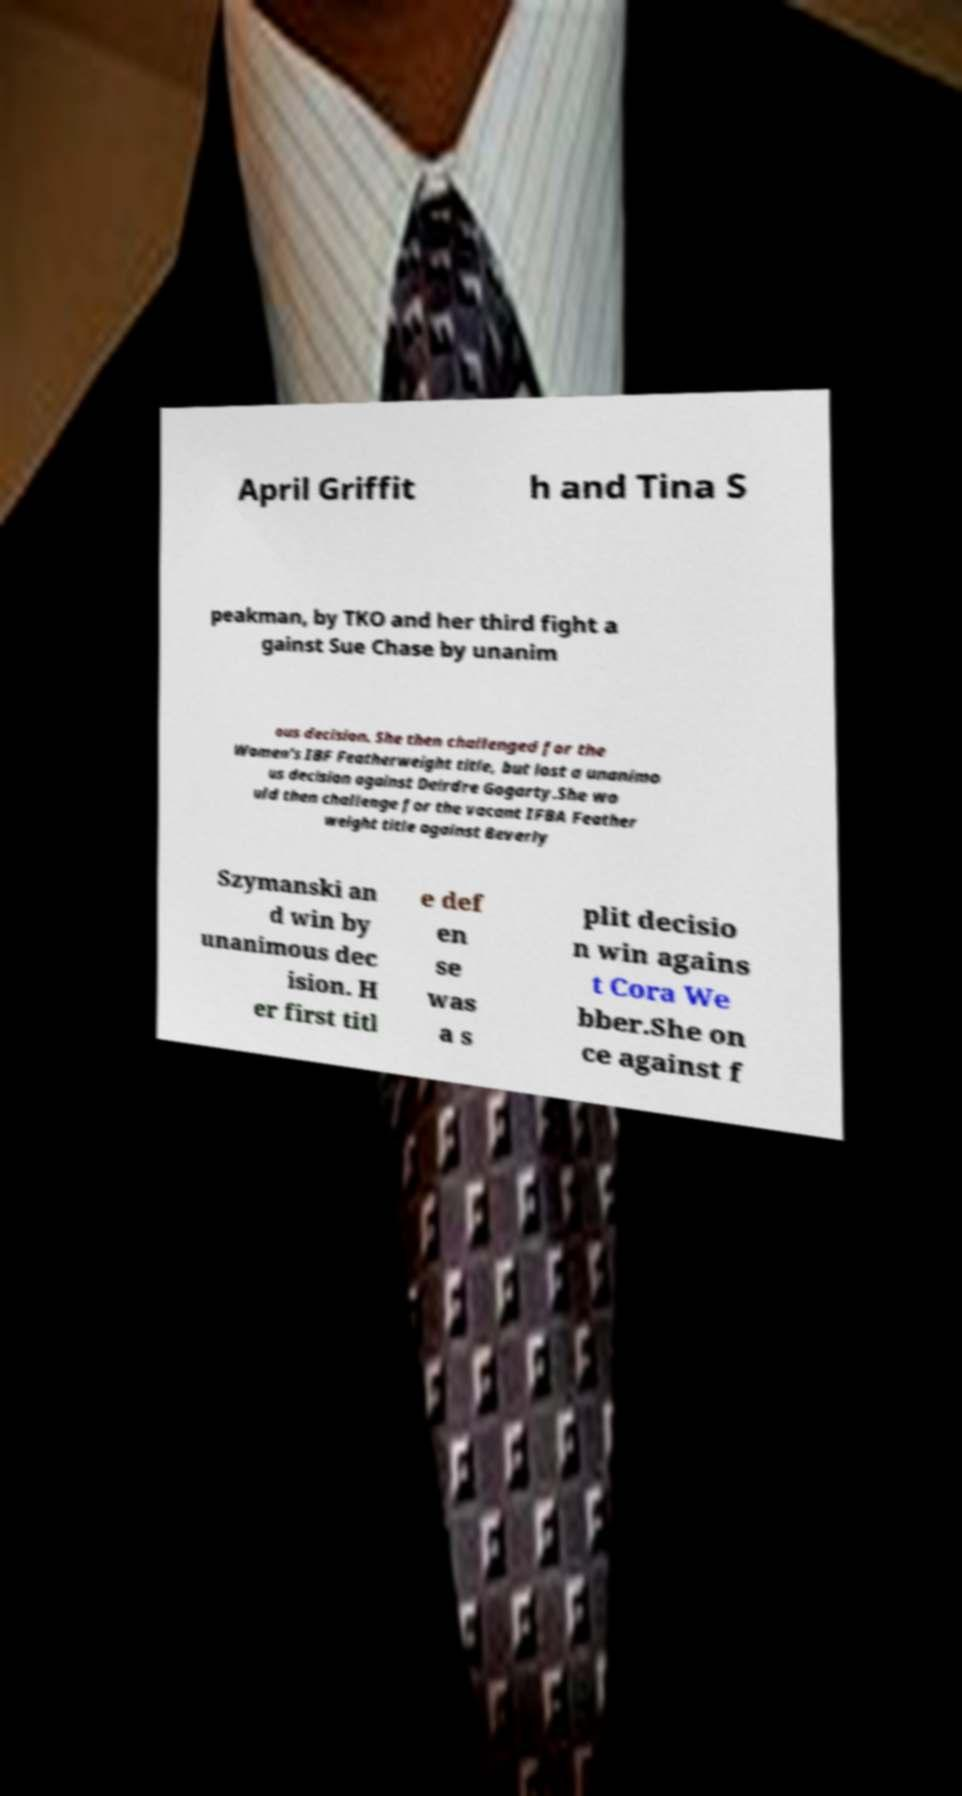What messages or text are displayed in this image? I need them in a readable, typed format. April Griffit h and Tina S peakman, by TKO and her third fight a gainst Sue Chase by unanim ous decision. She then challenged for the Women's IBF Featherweight title, but lost a unanimo us decision against Deirdre Gogarty.She wo uld then challenge for the vacant IFBA Feather weight title against Beverly Szymanski an d win by unanimous dec ision. H er first titl e def en se was a s plit decisio n win agains t Cora We bber.She on ce against f 